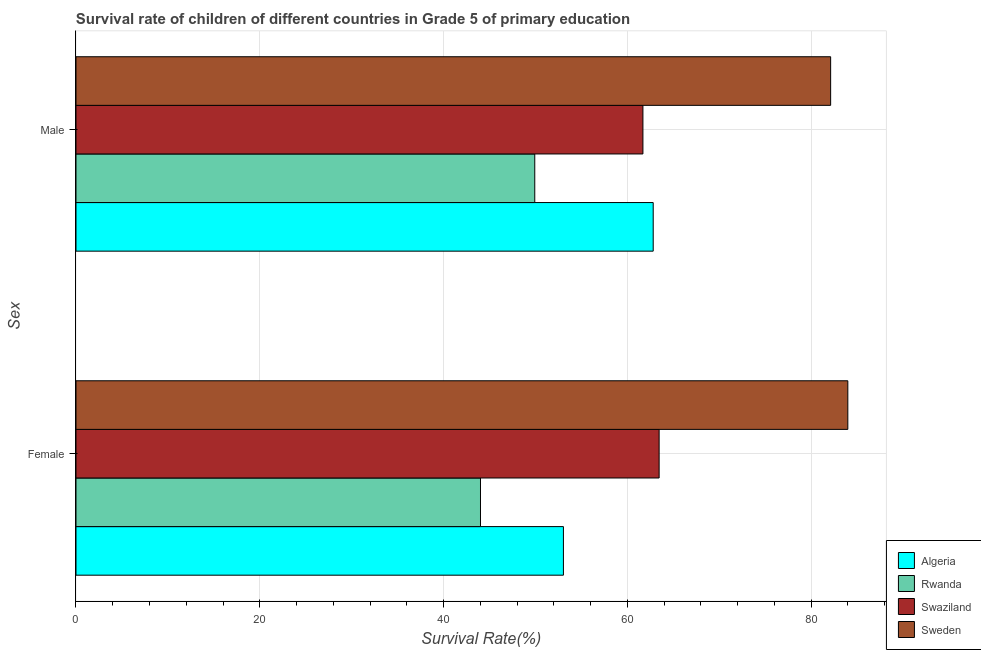How many groups of bars are there?
Keep it short and to the point. 2. Are the number of bars per tick equal to the number of legend labels?
Your response must be concise. Yes. Are the number of bars on each tick of the Y-axis equal?
Your answer should be compact. Yes. How many bars are there on the 1st tick from the top?
Provide a short and direct response. 4. What is the survival rate of male students in primary education in Algeria?
Offer a very short reply. 62.82. Across all countries, what is the maximum survival rate of female students in primary education?
Offer a very short reply. 83.99. Across all countries, what is the minimum survival rate of male students in primary education?
Your answer should be very brief. 49.93. In which country was the survival rate of female students in primary education minimum?
Ensure brevity in your answer.  Rwanda. What is the total survival rate of male students in primary education in the graph?
Provide a succinct answer. 256.56. What is the difference between the survival rate of male students in primary education in Sweden and that in Algeria?
Provide a succinct answer. 19.31. What is the difference between the survival rate of male students in primary education in Rwanda and the survival rate of female students in primary education in Algeria?
Make the answer very short. -3.12. What is the average survival rate of female students in primary education per country?
Offer a terse response. 61.13. What is the difference between the survival rate of female students in primary education and survival rate of male students in primary education in Swaziland?
Your answer should be compact. 1.76. What is the ratio of the survival rate of female students in primary education in Rwanda to that in Sweden?
Your answer should be compact. 0.52. Is the survival rate of female students in primary education in Algeria less than that in Sweden?
Make the answer very short. Yes. In how many countries, is the survival rate of male students in primary education greater than the average survival rate of male students in primary education taken over all countries?
Your answer should be very brief. 1. What does the 1st bar from the bottom in Male represents?
Your answer should be very brief. Algeria. Are all the bars in the graph horizontal?
Keep it short and to the point. Yes. Where does the legend appear in the graph?
Provide a succinct answer. Bottom right. How are the legend labels stacked?
Provide a short and direct response. Vertical. What is the title of the graph?
Offer a terse response. Survival rate of children of different countries in Grade 5 of primary education. Does "Kyrgyz Republic" appear as one of the legend labels in the graph?
Provide a succinct answer. No. What is the label or title of the X-axis?
Provide a succinct answer. Survival Rate(%). What is the label or title of the Y-axis?
Your answer should be very brief. Sex. What is the Survival Rate(%) in Algeria in Female?
Your answer should be very brief. 53.04. What is the Survival Rate(%) of Rwanda in Female?
Keep it short and to the point. 44.02. What is the Survival Rate(%) of Swaziland in Female?
Provide a succinct answer. 63.46. What is the Survival Rate(%) in Sweden in Female?
Your response must be concise. 83.99. What is the Survival Rate(%) of Algeria in Male?
Make the answer very short. 62.82. What is the Survival Rate(%) of Rwanda in Male?
Provide a short and direct response. 49.93. What is the Survival Rate(%) of Swaziland in Male?
Give a very brief answer. 61.7. What is the Survival Rate(%) in Sweden in Male?
Give a very brief answer. 82.12. Across all Sex, what is the maximum Survival Rate(%) of Algeria?
Provide a succinct answer. 62.82. Across all Sex, what is the maximum Survival Rate(%) in Rwanda?
Provide a succinct answer. 49.93. Across all Sex, what is the maximum Survival Rate(%) of Swaziland?
Ensure brevity in your answer.  63.46. Across all Sex, what is the maximum Survival Rate(%) in Sweden?
Your answer should be very brief. 83.99. Across all Sex, what is the minimum Survival Rate(%) in Algeria?
Your answer should be very brief. 53.04. Across all Sex, what is the minimum Survival Rate(%) in Rwanda?
Your answer should be compact. 44.02. Across all Sex, what is the minimum Survival Rate(%) of Swaziland?
Provide a succinct answer. 61.7. Across all Sex, what is the minimum Survival Rate(%) in Sweden?
Ensure brevity in your answer.  82.12. What is the total Survival Rate(%) of Algeria in the graph?
Offer a terse response. 115.86. What is the total Survival Rate(%) in Rwanda in the graph?
Keep it short and to the point. 93.94. What is the total Survival Rate(%) in Swaziland in the graph?
Offer a very short reply. 125.16. What is the total Survival Rate(%) in Sweden in the graph?
Your answer should be very brief. 166.12. What is the difference between the Survival Rate(%) in Algeria in Female and that in Male?
Ensure brevity in your answer.  -9.77. What is the difference between the Survival Rate(%) of Rwanda in Female and that in Male?
Ensure brevity in your answer.  -5.91. What is the difference between the Survival Rate(%) in Swaziland in Female and that in Male?
Provide a succinct answer. 1.76. What is the difference between the Survival Rate(%) of Sweden in Female and that in Male?
Make the answer very short. 1.87. What is the difference between the Survival Rate(%) of Algeria in Female and the Survival Rate(%) of Rwanda in Male?
Ensure brevity in your answer.  3.12. What is the difference between the Survival Rate(%) of Algeria in Female and the Survival Rate(%) of Swaziland in Male?
Your answer should be very brief. -8.65. What is the difference between the Survival Rate(%) in Algeria in Female and the Survival Rate(%) in Sweden in Male?
Your response must be concise. -29.08. What is the difference between the Survival Rate(%) of Rwanda in Female and the Survival Rate(%) of Swaziland in Male?
Provide a short and direct response. -17.68. What is the difference between the Survival Rate(%) in Rwanda in Female and the Survival Rate(%) in Sweden in Male?
Offer a terse response. -38.11. What is the difference between the Survival Rate(%) in Swaziland in Female and the Survival Rate(%) in Sweden in Male?
Offer a very short reply. -18.66. What is the average Survival Rate(%) in Algeria per Sex?
Your answer should be very brief. 57.93. What is the average Survival Rate(%) of Rwanda per Sex?
Offer a very short reply. 46.97. What is the average Survival Rate(%) in Swaziland per Sex?
Your answer should be compact. 62.58. What is the average Survival Rate(%) of Sweden per Sex?
Provide a short and direct response. 83.06. What is the difference between the Survival Rate(%) in Algeria and Survival Rate(%) in Rwanda in Female?
Offer a terse response. 9.03. What is the difference between the Survival Rate(%) in Algeria and Survival Rate(%) in Swaziland in Female?
Provide a succinct answer. -10.42. What is the difference between the Survival Rate(%) of Algeria and Survival Rate(%) of Sweden in Female?
Provide a short and direct response. -30.95. What is the difference between the Survival Rate(%) of Rwanda and Survival Rate(%) of Swaziland in Female?
Offer a terse response. -19.44. What is the difference between the Survival Rate(%) of Rwanda and Survival Rate(%) of Sweden in Female?
Provide a short and direct response. -39.98. What is the difference between the Survival Rate(%) in Swaziland and Survival Rate(%) in Sweden in Female?
Your answer should be very brief. -20.53. What is the difference between the Survival Rate(%) of Algeria and Survival Rate(%) of Rwanda in Male?
Your response must be concise. 12.89. What is the difference between the Survival Rate(%) of Algeria and Survival Rate(%) of Swaziland in Male?
Provide a short and direct response. 1.12. What is the difference between the Survival Rate(%) in Algeria and Survival Rate(%) in Sweden in Male?
Your answer should be compact. -19.31. What is the difference between the Survival Rate(%) of Rwanda and Survival Rate(%) of Swaziland in Male?
Your answer should be very brief. -11.77. What is the difference between the Survival Rate(%) of Rwanda and Survival Rate(%) of Sweden in Male?
Provide a short and direct response. -32.2. What is the difference between the Survival Rate(%) in Swaziland and Survival Rate(%) in Sweden in Male?
Provide a short and direct response. -20.43. What is the ratio of the Survival Rate(%) in Algeria in Female to that in Male?
Provide a succinct answer. 0.84. What is the ratio of the Survival Rate(%) in Rwanda in Female to that in Male?
Offer a very short reply. 0.88. What is the ratio of the Survival Rate(%) in Swaziland in Female to that in Male?
Your answer should be very brief. 1.03. What is the ratio of the Survival Rate(%) of Sweden in Female to that in Male?
Give a very brief answer. 1.02. What is the difference between the highest and the second highest Survival Rate(%) in Algeria?
Your answer should be very brief. 9.77. What is the difference between the highest and the second highest Survival Rate(%) in Rwanda?
Provide a short and direct response. 5.91. What is the difference between the highest and the second highest Survival Rate(%) in Swaziland?
Ensure brevity in your answer.  1.76. What is the difference between the highest and the second highest Survival Rate(%) in Sweden?
Your answer should be very brief. 1.87. What is the difference between the highest and the lowest Survival Rate(%) of Algeria?
Keep it short and to the point. 9.77. What is the difference between the highest and the lowest Survival Rate(%) of Rwanda?
Provide a short and direct response. 5.91. What is the difference between the highest and the lowest Survival Rate(%) of Swaziland?
Your answer should be compact. 1.76. What is the difference between the highest and the lowest Survival Rate(%) of Sweden?
Your answer should be very brief. 1.87. 